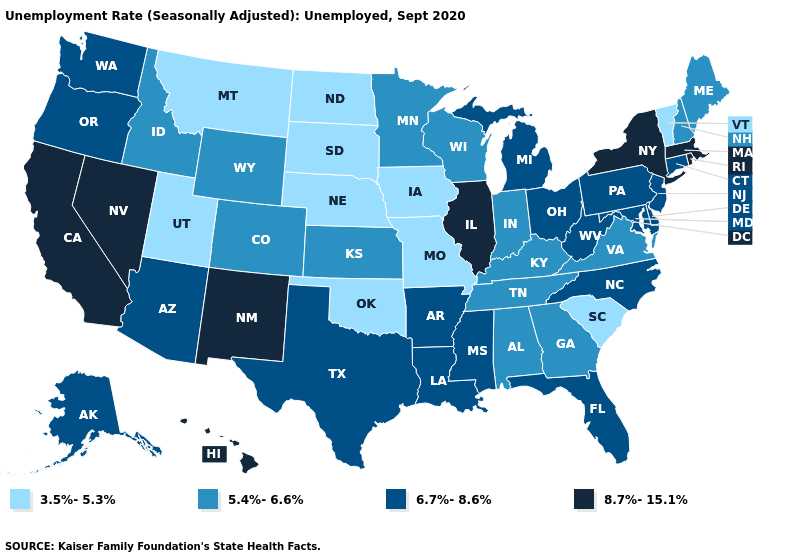What is the value of North Dakota?
Keep it brief. 3.5%-5.3%. Name the states that have a value in the range 6.7%-8.6%?
Concise answer only. Alaska, Arizona, Arkansas, Connecticut, Delaware, Florida, Louisiana, Maryland, Michigan, Mississippi, New Jersey, North Carolina, Ohio, Oregon, Pennsylvania, Texas, Washington, West Virginia. Does the first symbol in the legend represent the smallest category?
Concise answer only. Yes. What is the lowest value in states that border Kentucky?
Answer briefly. 3.5%-5.3%. Among the states that border Colorado , which have the highest value?
Keep it brief. New Mexico. What is the lowest value in the USA?
Short answer required. 3.5%-5.3%. Name the states that have a value in the range 3.5%-5.3%?
Write a very short answer. Iowa, Missouri, Montana, Nebraska, North Dakota, Oklahoma, South Carolina, South Dakota, Utah, Vermont. What is the highest value in the South ?
Concise answer only. 6.7%-8.6%. Name the states that have a value in the range 6.7%-8.6%?
Be succinct. Alaska, Arizona, Arkansas, Connecticut, Delaware, Florida, Louisiana, Maryland, Michigan, Mississippi, New Jersey, North Carolina, Ohio, Oregon, Pennsylvania, Texas, Washington, West Virginia. Does Louisiana have a higher value than Ohio?
Give a very brief answer. No. Does the first symbol in the legend represent the smallest category?
Write a very short answer. Yes. Does California have the same value as Oregon?
Answer briefly. No. Does the first symbol in the legend represent the smallest category?
Short answer required. Yes. What is the lowest value in the West?
Answer briefly. 3.5%-5.3%. Name the states that have a value in the range 8.7%-15.1%?
Give a very brief answer. California, Hawaii, Illinois, Massachusetts, Nevada, New Mexico, New York, Rhode Island. 